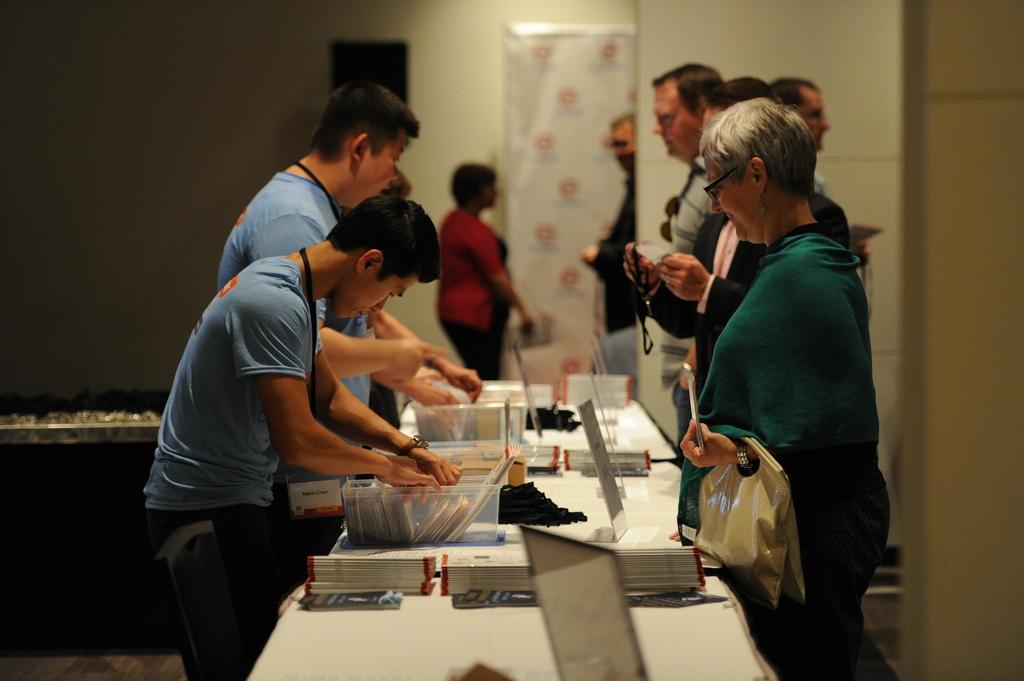Describe this image in one or two sentences. There is a group of people. They are standing. On the left side of the persons are wearing a id card. On the right side of the persons are holding a bag and card. There is a table. There is a box,papers ,name board on a table. We can see in background wall and poster. 